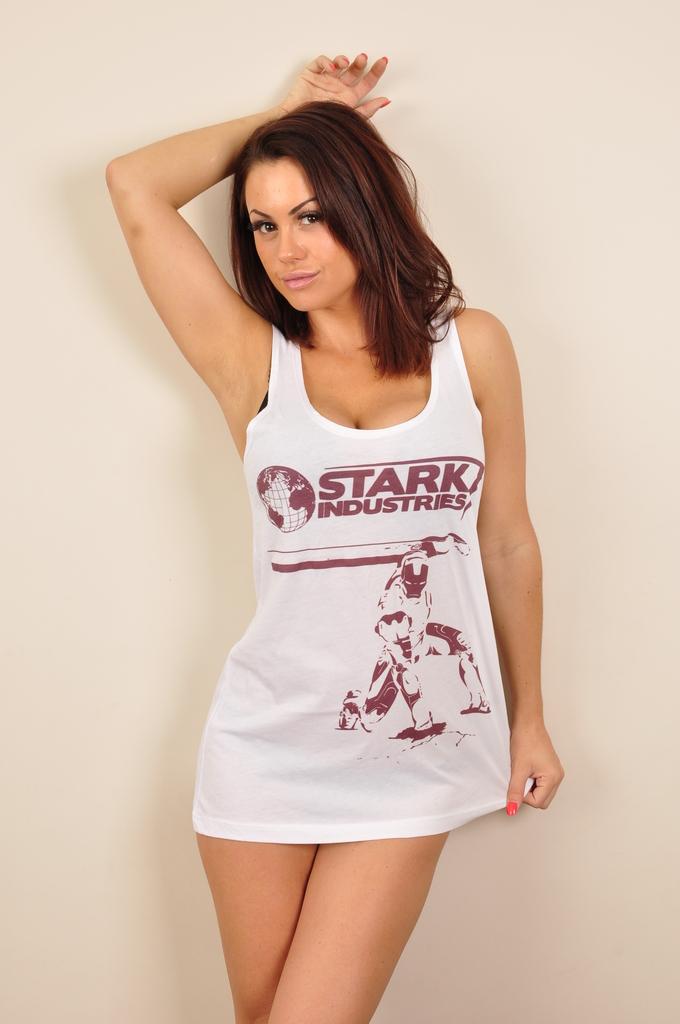Whose industries does the woman have on her shirt?
Give a very brief answer. Stark. What is the bottom word on the lady's t-shirt?
Give a very brief answer. Industries. 